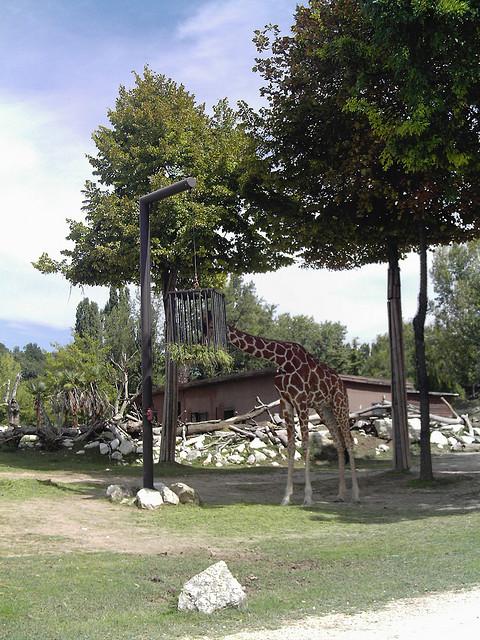What kind of rock is on the ground?
Quick response, please. White. Is this animal standing in the sun or shade?
Concise answer only. Shade. Where is this taken?
Write a very short answer. Zoo. Are there any giraffes under the pavilion?
Be succinct. No. What is hanging from the pole?
Answer briefly. Food. 